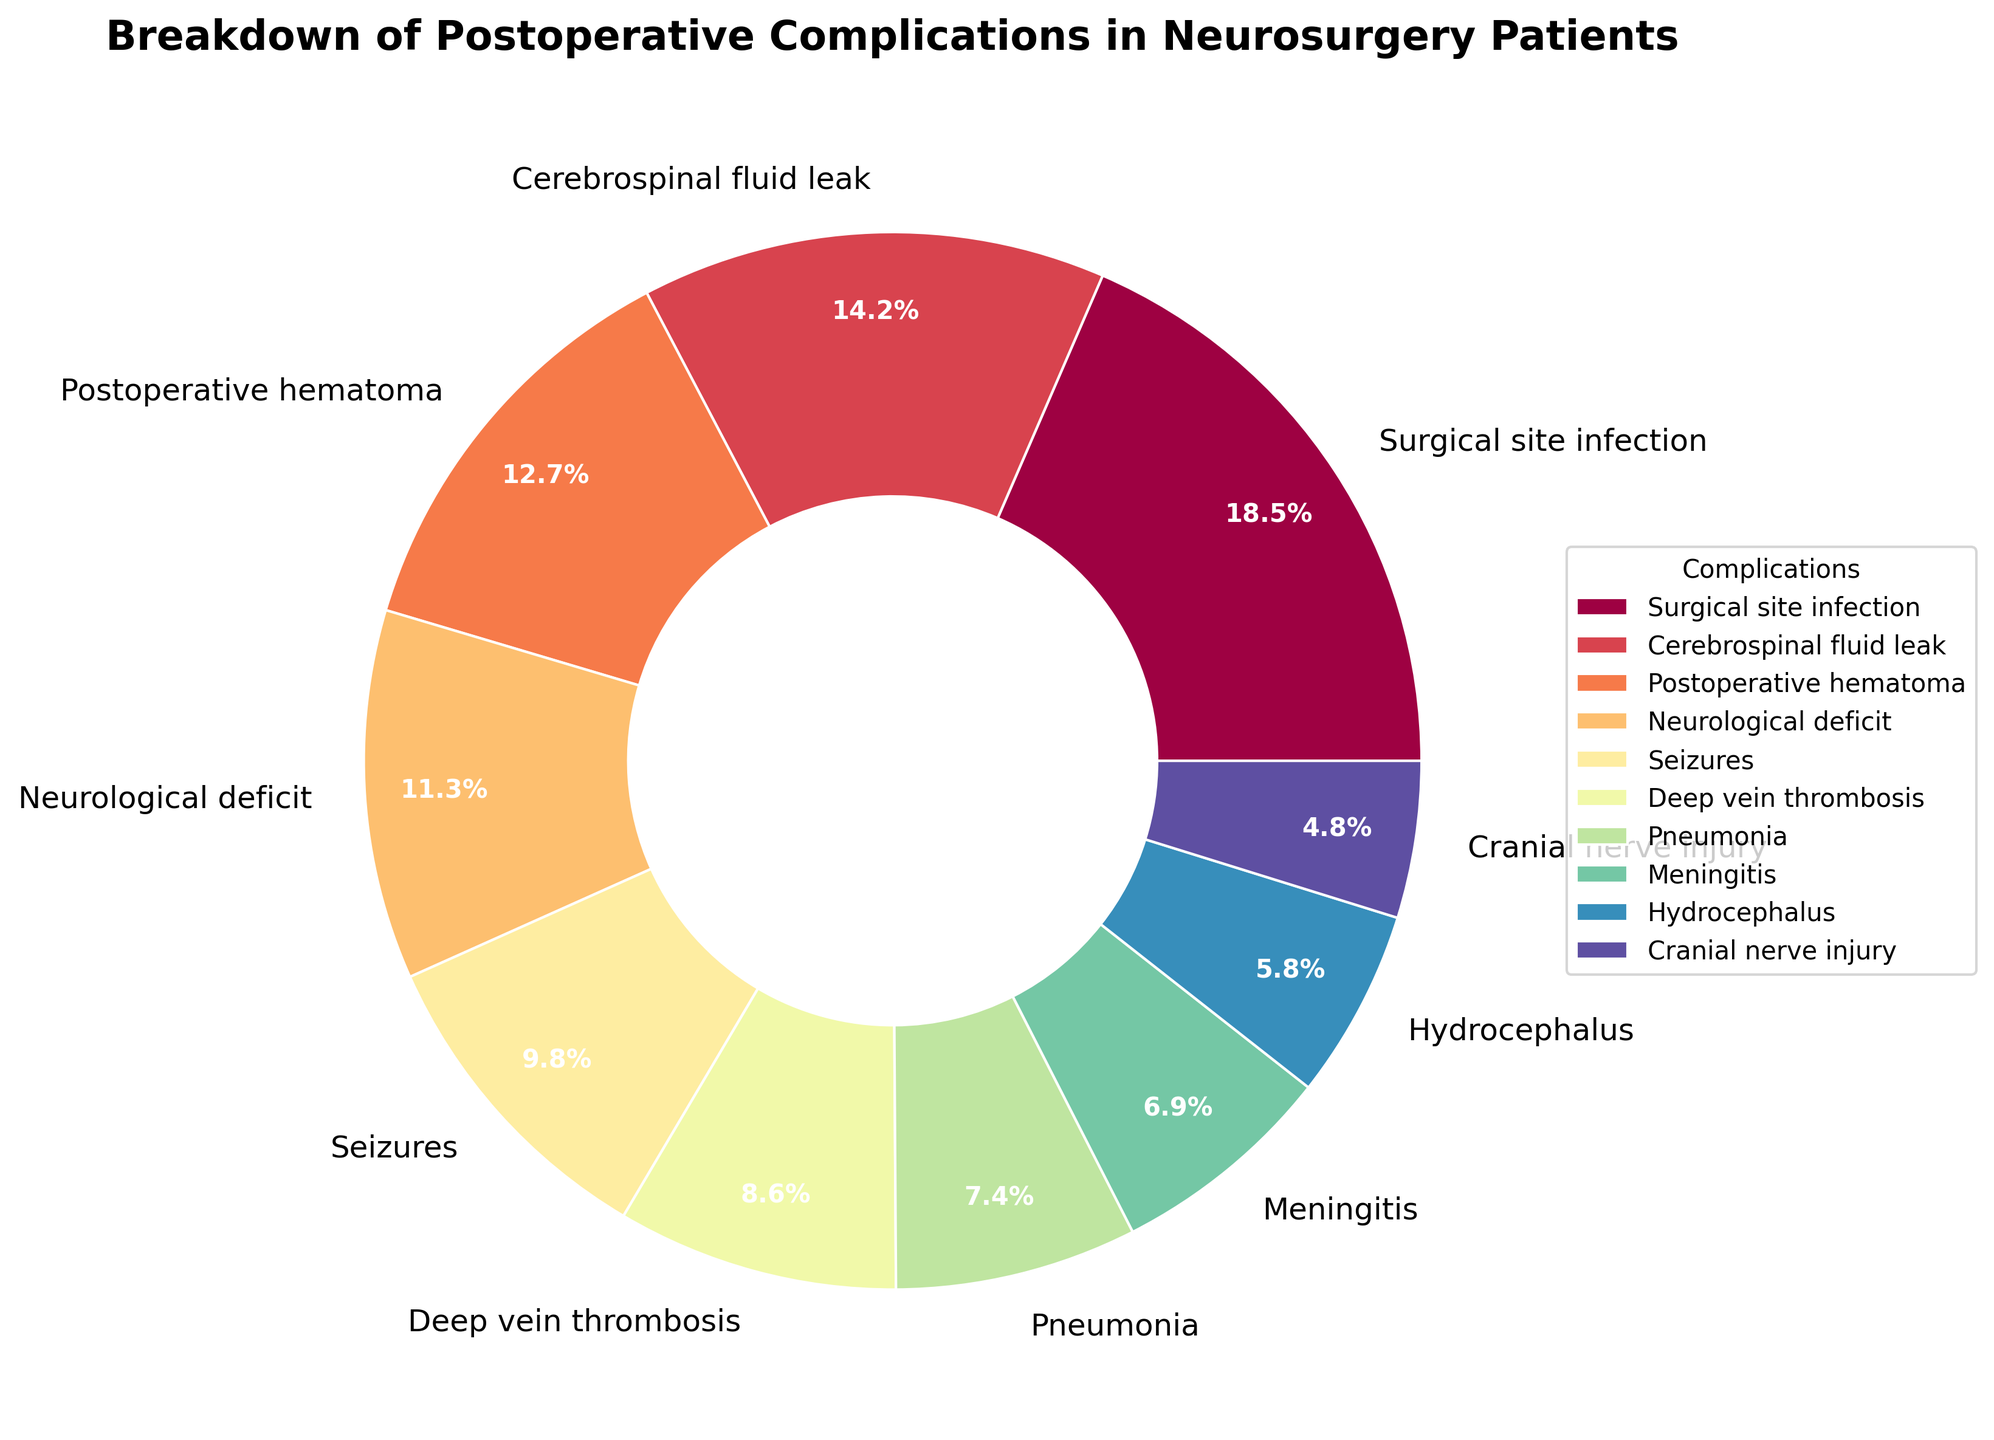Which complication has the highest percentage? By observing the pie chart, it's evident that the segment labeled 'Surgical site infection' represents the largest portion.
Answer: Surgical site infection Compare the percentages of deep vein thrombosis and meningitis. Which is higher and by how much? Deep vein thrombosis (8.6%) is compared to meningitis (6.9%). The difference in their percentages can be calculated as 8.6% - 6.9% = 1.7%.
Answer: Deep vein thrombosis by 1.7% What percentage of postoperative complications is attributed to neurological deficit and seizures combined? Neurological deficit accounts for 11.3% and seizures account for 9.8%. Adding these together, 11.3% + 9.8% = 21.1%.
Answer: 21.1% How does the percentage of hydrocephalus compare to cranial nerve injury? Comparing hydrocephalus (5.8%) to cranial nerve injury (4.8%), hydrocephalus is higher.
Answer: Hydrocephalus Which two complications together make up about one-third of the total complications? Surgical site infection, at 18.5%, combined with cerebrospinal fluid leak at 14.2%, sums up to 32.7%, which is approximately one-third (33.3%) of the total.
Answer: Surgical site infection and cerebrospinal fluid leak What is the difference in percentage between the highest and lowest complications? The highest complication is surgical site infection at 18.5%, and the lowest is cranial nerve injury at 4.8%. The difference is 18.5% - 4.8% = 13.7%.
Answer: 13.7% Which complication is represented by the smallest segment on the chart? Observing the pie chart, the smallest segment corresponds to 'Cranial nerve injury,' which is 4.8%.
Answer: Cranial nerve injury List the complications that take up less than 10% each. By checking the pie chart, the complications with each under 10% are seizures (9.8%), deep vein thrombosis (8.6%), pneumonia (7.4%), meningitis (6.9%), hydrocephalus (5.8%), and cranial nerve injury (4.8%).
Answer: Seizures, deep vein thrombosis, pneumonia, meningitis, hydrocephalus, cranial nerve injury If the total number of complications reported were 500, how many were related to pneumonia? If pneumonia accounts for 7.4% of the complications, then the number related to pneumonia would be 7.4% of 500. This can be calculated as (7.4 / 100) * 500 = 37.
Answer: 37 